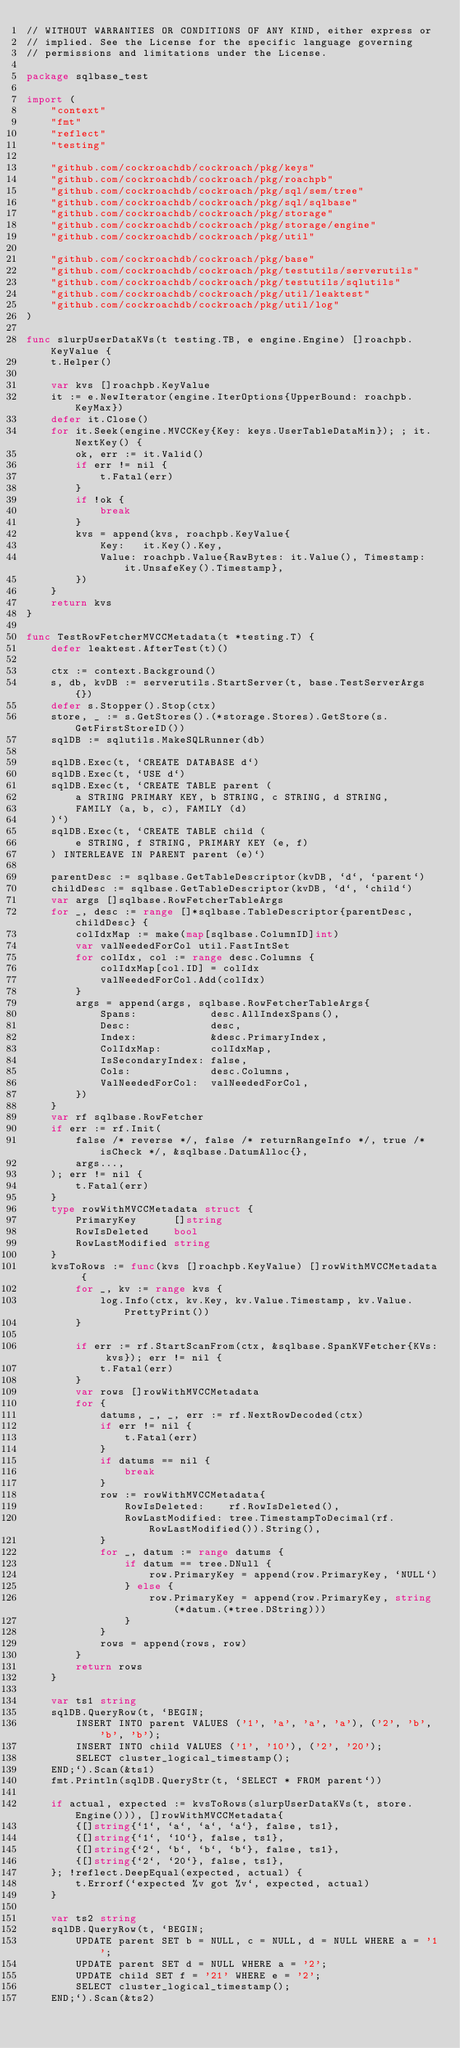Convert code to text. <code><loc_0><loc_0><loc_500><loc_500><_Go_>// WITHOUT WARRANTIES OR CONDITIONS OF ANY KIND, either express or
// implied. See the License for the specific language governing
// permissions and limitations under the License.

package sqlbase_test

import (
	"context"
	"fmt"
	"reflect"
	"testing"

	"github.com/cockroachdb/cockroach/pkg/keys"
	"github.com/cockroachdb/cockroach/pkg/roachpb"
	"github.com/cockroachdb/cockroach/pkg/sql/sem/tree"
	"github.com/cockroachdb/cockroach/pkg/sql/sqlbase"
	"github.com/cockroachdb/cockroach/pkg/storage"
	"github.com/cockroachdb/cockroach/pkg/storage/engine"
	"github.com/cockroachdb/cockroach/pkg/util"

	"github.com/cockroachdb/cockroach/pkg/base"
	"github.com/cockroachdb/cockroach/pkg/testutils/serverutils"
	"github.com/cockroachdb/cockroach/pkg/testutils/sqlutils"
	"github.com/cockroachdb/cockroach/pkg/util/leaktest"
	"github.com/cockroachdb/cockroach/pkg/util/log"
)

func slurpUserDataKVs(t testing.TB, e engine.Engine) []roachpb.KeyValue {
	t.Helper()

	var kvs []roachpb.KeyValue
	it := e.NewIterator(engine.IterOptions{UpperBound: roachpb.KeyMax})
	defer it.Close()
	for it.Seek(engine.MVCCKey{Key: keys.UserTableDataMin}); ; it.NextKey() {
		ok, err := it.Valid()
		if err != nil {
			t.Fatal(err)
		}
		if !ok {
			break
		}
		kvs = append(kvs, roachpb.KeyValue{
			Key:   it.Key().Key,
			Value: roachpb.Value{RawBytes: it.Value(), Timestamp: it.UnsafeKey().Timestamp},
		})
	}
	return kvs
}

func TestRowFetcherMVCCMetadata(t *testing.T) {
	defer leaktest.AfterTest(t)()

	ctx := context.Background()
	s, db, kvDB := serverutils.StartServer(t, base.TestServerArgs{})
	defer s.Stopper().Stop(ctx)
	store, _ := s.GetStores().(*storage.Stores).GetStore(s.GetFirstStoreID())
	sqlDB := sqlutils.MakeSQLRunner(db)

	sqlDB.Exec(t, `CREATE DATABASE d`)
	sqlDB.Exec(t, `USE d`)
	sqlDB.Exec(t, `CREATE TABLE parent (
		a STRING PRIMARY KEY, b STRING, c STRING, d STRING,
		FAMILY (a, b, c), FAMILY (d)
	)`)
	sqlDB.Exec(t, `CREATE TABLE child (
		e STRING, f STRING, PRIMARY KEY (e, f)
	) INTERLEAVE IN PARENT parent (e)`)

	parentDesc := sqlbase.GetTableDescriptor(kvDB, `d`, `parent`)
	childDesc := sqlbase.GetTableDescriptor(kvDB, `d`, `child`)
	var args []sqlbase.RowFetcherTableArgs
	for _, desc := range []*sqlbase.TableDescriptor{parentDesc, childDesc} {
		colIdxMap := make(map[sqlbase.ColumnID]int)
		var valNeededForCol util.FastIntSet
		for colIdx, col := range desc.Columns {
			colIdxMap[col.ID] = colIdx
			valNeededForCol.Add(colIdx)
		}
		args = append(args, sqlbase.RowFetcherTableArgs{
			Spans:            desc.AllIndexSpans(),
			Desc:             desc,
			Index:            &desc.PrimaryIndex,
			ColIdxMap:        colIdxMap,
			IsSecondaryIndex: false,
			Cols:             desc.Columns,
			ValNeededForCol:  valNeededForCol,
		})
	}
	var rf sqlbase.RowFetcher
	if err := rf.Init(
		false /* reverse */, false /* returnRangeInfo */, true /* isCheck */, &sqlbase.DatumAlloc{},
		args...,
	); err != nil {
		t.Fatal(err)
	}
	type rowWithMVCCMetadata struct {
		PrimaryKey      []string
		RowIsDeleted    bool
		RowLastModified string
	}
	kvsToRows := func(kvs []roachpb.KeyValue) []rowWithMVCCMetadata {
		for _, kv := range kvs {
			log.Info(ctx, kv.Key, kv.Value.Timestamp, kv.Value.PrettyPrint())
		}

		if err := rf.StartScanFrom(ctx, &sqlbase.SpanKVFetcher{KVs: kvs}); err != nil {
			t.Fatal(err)
		}
		var rows []rowWithMVCCMetadata
		for {
			datums, _, _, err := rf.NextRowDecoded(ctx)
			if err != nil {
				t.Fatal(err)
			}
			if datums == nil {
				break
			}
			row := rowWithMVCCMetadata{
				RowIsDeleted:    rf.RowIsDeleted(),
				RowLastModified: tree.TimestampToDecimal(rf.RowLastModified()).String(),
			}
			for _, datum := range datums {
				if datum == tree.DNull {
					row.PrimaryKey = append(row.PrimaryKey, `NULL`)
				} else {
					row.PrimaryKey = append(row.PrimaryKey, string(*datum.(*tree.DString)))
				}
			}
			rows = append(rows, row)
		}
		return rows
	}

	var ts1 string
	sqlDB.QueryRow(t, `BEGIN;
		INSERT INTO parent VALUES ('1', 'a', 'a', 'a'), ('2', 'b', 'b', 'b');
		INSERT INTO child VALUES ('1', '10'), ('2', '20');
		SELECT cluster_logical_timestamp();
	END;`).Scan(&ts1)
	fmt.Println(sqlDB.QueryStr(t, `SELECT * FROM parent`))

	if actual, expected := kvsToRows(slurpUserDataKVs(t, store.Engine())), []rowWithMVCCMetadata{
		{[]string{`1`, `a`, `a`, `a`}, false, ts1},
		{[]string{`1`, `10`}, false, ts1},
		{[]string{`2`, `b`, `b`, `b`}, false, ts1},
		{[]string{`2`, `20`}, false, ts1},
	}; !reflect.DeepEqual(expected, actual) {
		t.Errorf(`expected %v got %v`, expected, actual)
	}

	var ts2 string
	sqlDB.QueryRow(t, `BEGIN;
		UPDATE parent SET b = NULL, c = NULL, d = NULL WHERE a = '1';
		UPDATE parent SET d = NULL WHERE a = '2';
		UPDATE child SET f = '21' WHERE e = '2';
		SELECT cluster_logical_timestamp();
	END;`).Scan(&ts2)</code> 